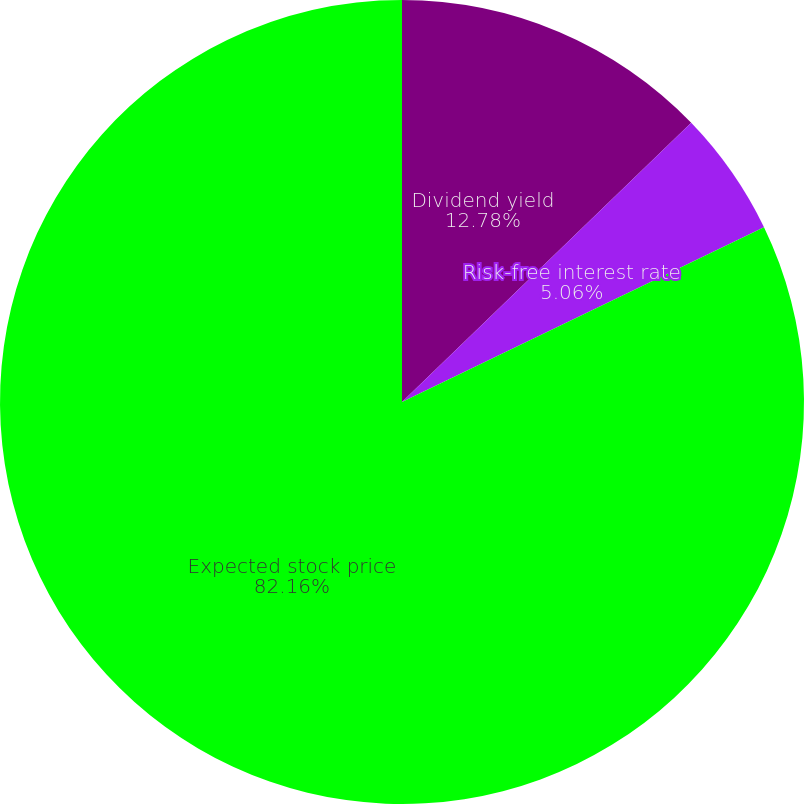<chart> <loc_0><loc_0><loc_500><loc_500><pie_chart><fcel>Dividend yield<fcel>Risk-free interest rate<fcel>Expected stock price<nl><fcel>12.78%<fcel>5.06%<fcel>82.16%<nl></chart> 